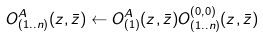<formula> <loc_0><loc_0><loc_500><loc_500>O _ { ( 1 . . n ) } ^ { A } ( z , \bar { z } ) \leftarrow O _ { ( 1 ) } ^ { A } ( z , \bar { z } ) O _ { ( 1 . . n ) } ^ { ( 0 , 0 ) } ( z , \bar { z } )</formula> 